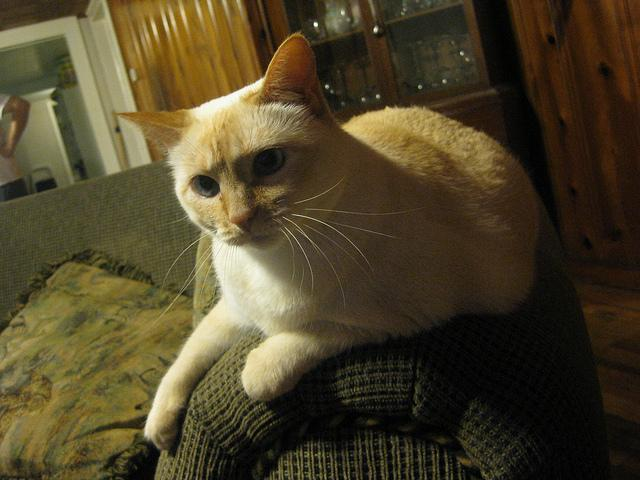What type of cat is this? domestic 